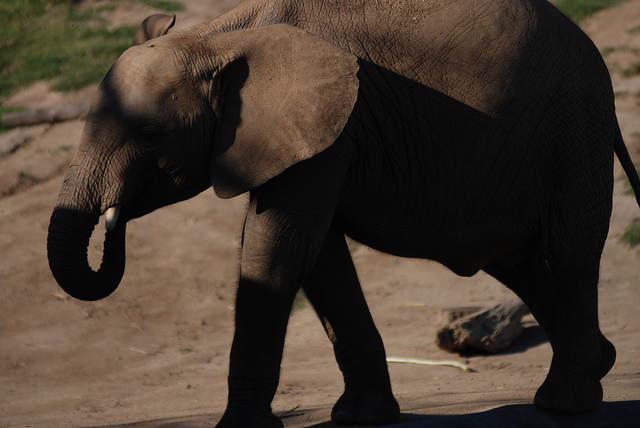<image>Are there trees in this picture? No, there are no trees in this picture. Are there trees in this picture? There are no trees in this picture. 